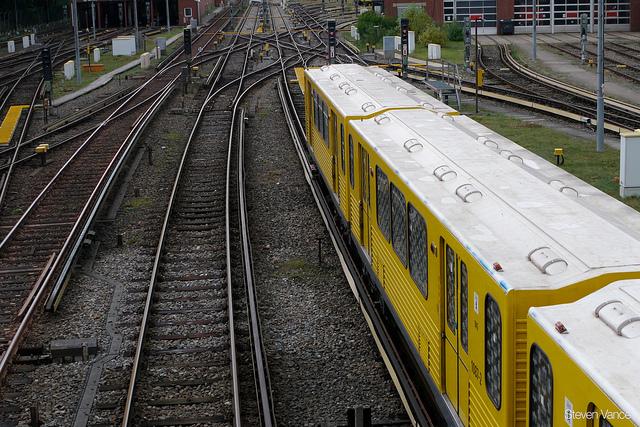What color is the train?
Answer briefly. Yellow. Are there any people next to the train?
Answer briefly. No. How many tracks are seen?
Be succinct. 6. What is the color of the roof the train?
Short answer required. White. Is this a train intersection?
Concise answer only. Yes. What color is the track?
Quick response, please. Gray. 